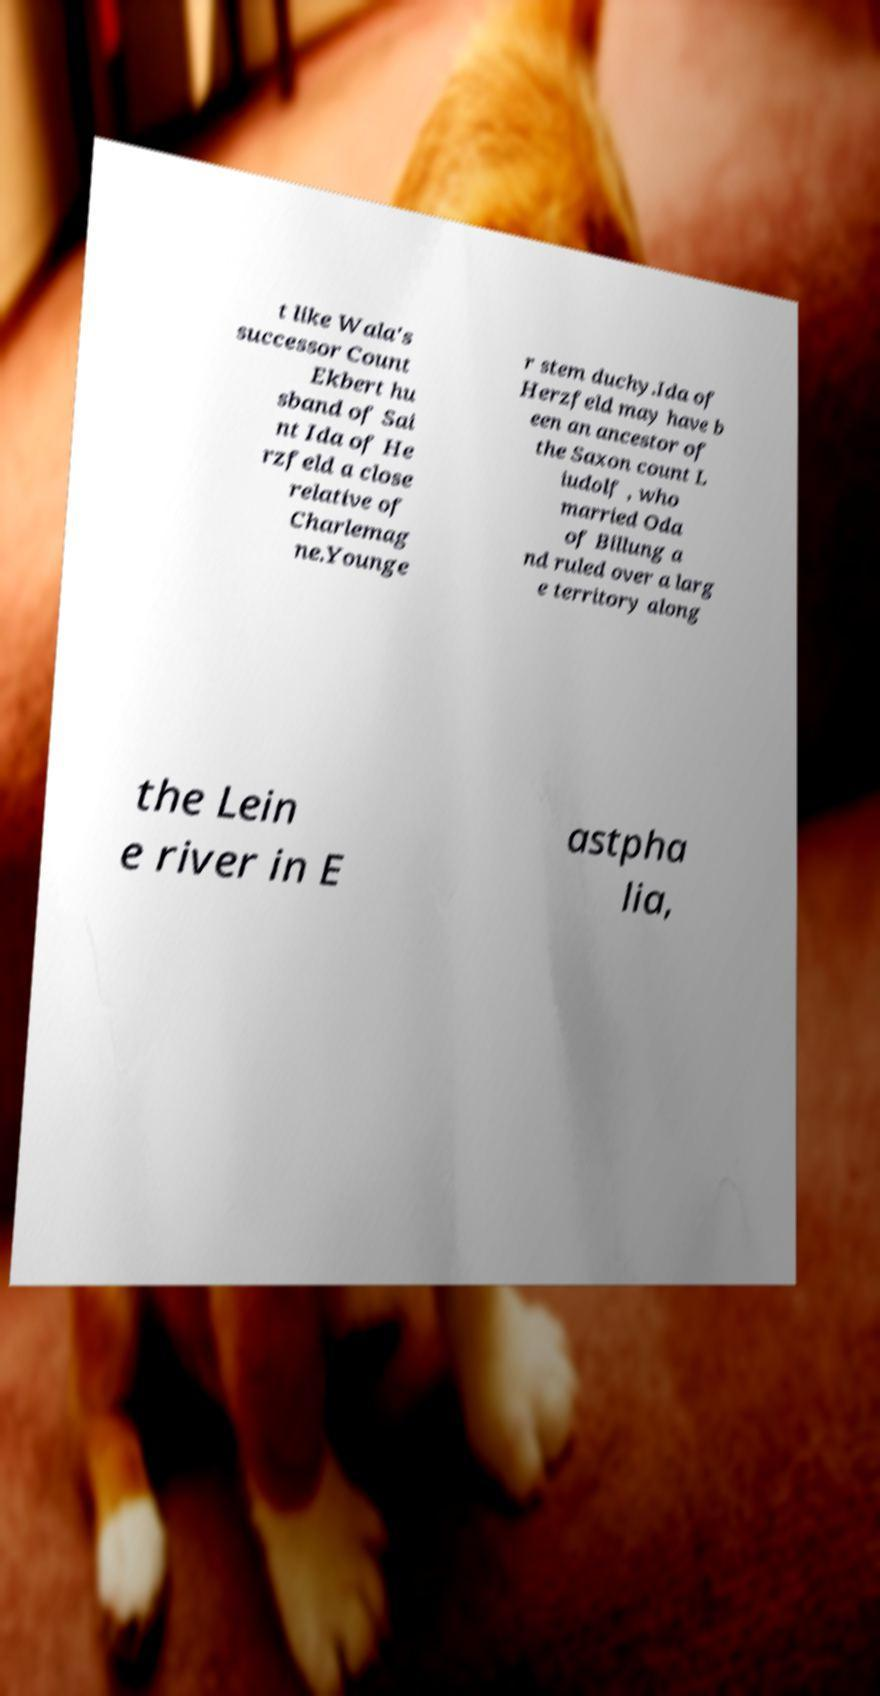Can you read and provide the text displayed in the image?This photo seems to have some interesting text. Can you extract and type it out for me? t like Wala's successor Count Ekbert hu sband of Sai nt Ida of He rzfeld a close relative of Charlemag ne.Younge r stem duchy.Ida of Herzfeld may have b een an ancestor of the Saxon count L iudolf , who married Oda of Billung a nd ruled over a larg e territory along the Lein e river in E astpha lia, 